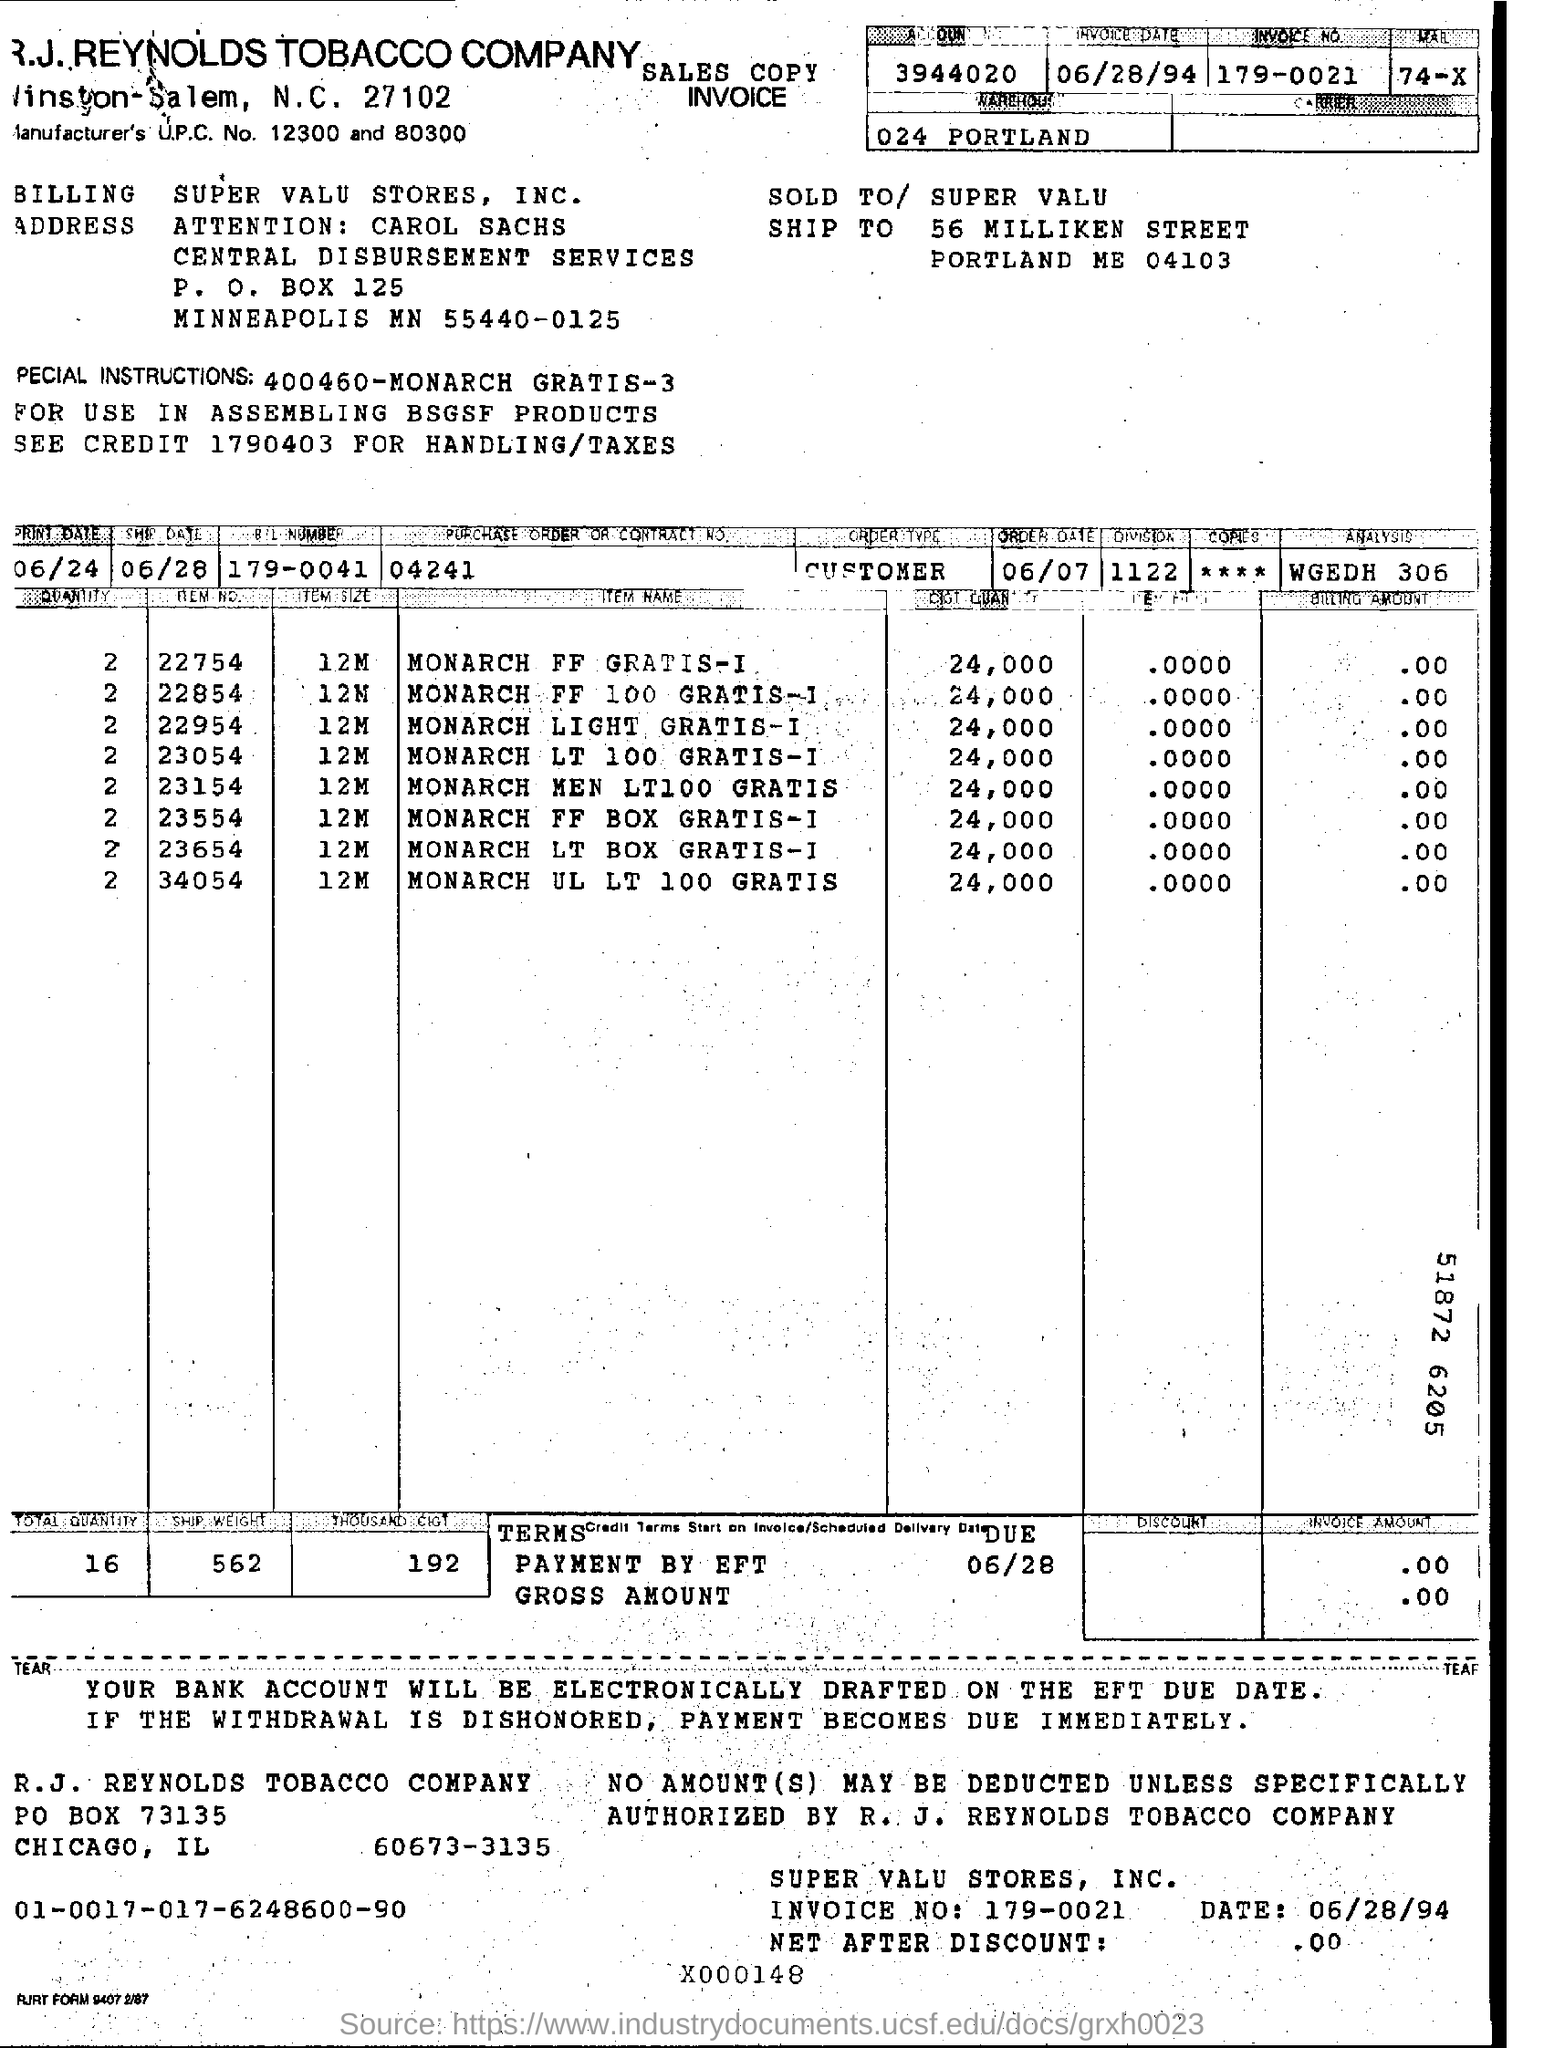Draw attention to some important aspects in this diagram. The invoice number is 179-0021. The purchase order or contract number is 04241. 